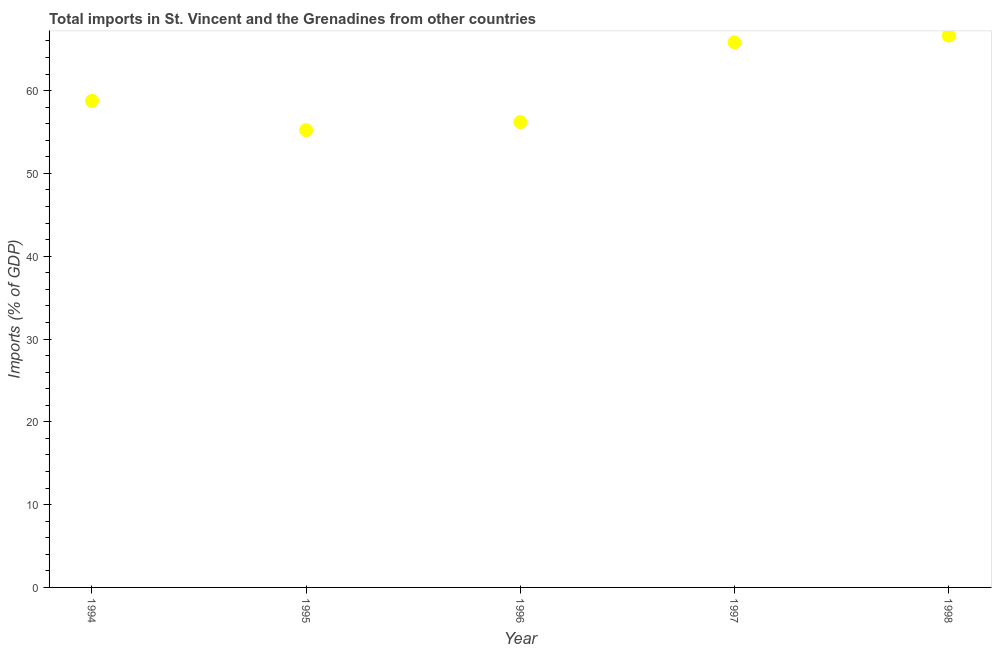What is the total imports in 1996?
Ensure brevity in your answer.  56.2. Across all years, what is the maximum total imports?
Your answer should be compact. 66.65. Across all years, what is the minimum total imports?
Ensure brevity in your answer.  55.22. In which year was the total imports maximum?
Your answer should be compact. 1998. In which year was the total imports minimum?
Provide a short and direct response. 1995. What is the sum of the total imports?
Offer a terse response. 302.66. What is the difference between the total imports in 1995 and 1998?
Keep it short and to the point. -11.43. What is the average total imports per year?
Keep it short and to the point. 60.53. What is the median total imports?
Offer a terse response. 58.76. In how many years, is the total imports greater than 30 %?
Ensure brevity in your answer.  5. Do a majority of the years between 1996 and 1997 (inclusive) have total imports greater than 42 %?
Make the answer very short. Yes. What is the ratio of the total imports in 1997 to that in 1998?
Your answer should be compact. 0.99. What is the difference between the highest and the second highest total imports?
Ensure brevity in your answer.  0.82. Is the sum of the total imports in 1996 and 1998 greater than the maximum total imports across all years?
Provide a succinct answer. Yes. What is the difference between the highest and the lowest total imports?
Provide a short and direct response. 11.43. In how many years, is the total imports greater than the average total imports taken over all years?
Your answer should be compact. 2. How many years are there in the graph?
Your answer should be very brief. 5. What is the title of the graph?
Offer a very short reply. Total imports in St. Vincent and the Grenadines from other countries. What is the label or title of the Y-axis?
Make the answer very short. Imports (% of GDP). What is the Imports (% of GDP) in 1994?
Your response must be concise. 58.76. What is the Imports (% of GDP) in 1995?
Ensure brevity in your answer.  55.22. What is the Imports (% of GDP) in 1996?
Provide a short and direct response. 56.2. What is the Imports (% of GDP) in 1997?
Your answer should be compact. 65.83. What is the Imports (% of GDP) in 1998?
Your response must be concise. 66.65. What is the difference between the Imports (% of GDP) in 1994 and 1995?
Offer a very short reply. 3.54. What is the difference between the Imports (% of GDP) in 1994 and 1996?
Ensure brevity in your answer.  2.56. What is the difference between the Imports (% of GDP) in 1994 and 1997?
Make the answer very short. -7.07. What is the difference between the Imports (% of GDP) in 1994 and 1998?
Give a very brief answer. -7.89. What is the difference between the Imports (% of GDP) in 1995 and 1996?
Keep it short and to the point. -0.97. What is the difference between the Imports (% of GDP) in 1995 and 1997?
Ensure brevity in your answer.  -10.61. What is the difference between the Imports (% of GDP) in 1995 and 1998?
Your answer should be very brief. -11.43. What is the difference between the Imports (% of GDP) in 1996 and 1997?
Give a very brief answer. -9.64. What is the difference between the Imports (% of GDP) in 1996 and 1998?
Your answer should be very brief. -10.45. What is the difference between the Imports (% of GDP) in 1997 and 1998?
Provide a short and direct response. -0.82. What is the ratio of the Imports (% of GDP) in 1994 to that in 1995?
Make the answer very short. 1.06. What is the ratio of the Imports (% of GDP) in 1994 to that in 1996?
Make the answer very short. 1.05. What is the ratio of the Imports (% of GDP) in 1994 to that in 1997?
Offer a very short reply. 0.89. What is the ratio of the Imports (% of GDP) in 1994 to that in 1998?
Offer a terse response. 0.88. What is the ratio of the Imports (% of GDP) in 1995 to that in 1997?
Your response must be concise. 0.84. What is the ratio of the Imports (% of GDP) in 1995 to that in 1998?
Provide a short and direct response. 0.83. What is the ratio of the Imports (% of GDP) in 1996 to that in 1997?
Provide a short and direct response. 0.85. What is the ratio of the Imports (% of GDP) in 1996 to that in 1998?
Provide a succinct answer. 0.84. 